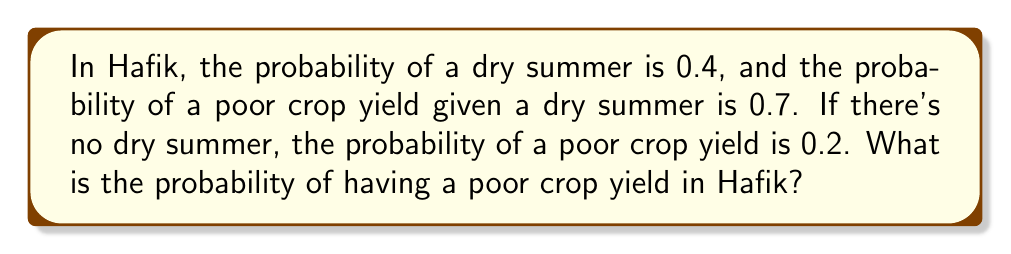Could you help me with this problem? Let's approach this step-by-step using the law of total probability:

1) Define events:
   D: Dry summer
   P: Poor crop yield

2) Given probabilities:
   $P(D) = 0.4$
   $P(P|D) = 0.7$
   $P(P|\text{not }D) = 0.2$

3) We need to find $P(P)$. Using the law of total probability:

   $P(P) = P(P|D) \cdot P(D) + P(P|\text{not }D) \cdot P(\text{not }D)$

4) We know $P(\text{not }D) = 1 - P(D) = 1 - 0.4 = 0.6$

5) Now, let's substitute the values:

   $P(P) = 0.7 \cdot 0.4 + 0.2 \cdot 0.6$

6) Calculate:
   $P(P) = 0.28 + 0.12 = 0.40$

Therefore, the probability of having a poor crop yield in Hafik is 0.40 or 40%.
Answer: 0.40 